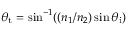Convert formula to latex. <formula><loc_0><loc_0><loc_500><loc_500>\theta _ { t } = \sin ^ { - 1 } ( ( n _ { 1 } / n _ { 2 } ) \sin \theta _ { i } )</formula> 